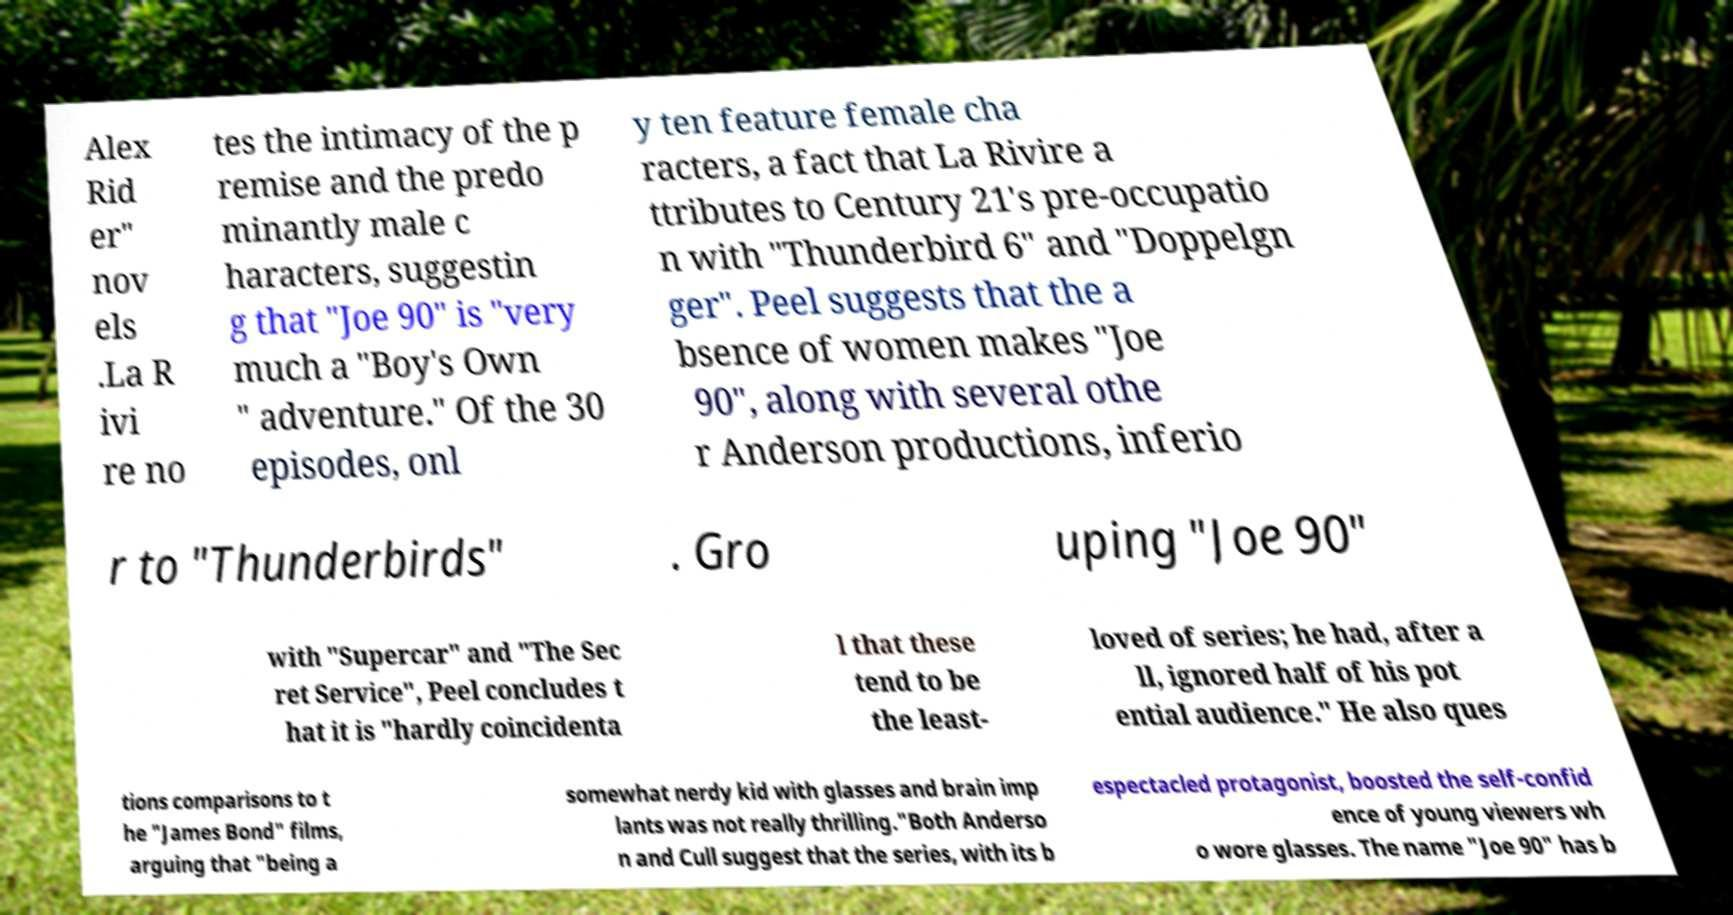I need the written content from this picture converted into text. Can you do that? Alex Rid er" nov els .La R ivi re no tes the intimacy of the p remise and the predo minantly male c haracters, suggestin g that "Joe 90" is "very much a "Boy's Own " adventure." Of the 30 episodes, onl y ten feature female cha racters, a fact that La Rivire a ttributes to Century 21's pre-occupatio n with "Thunderbird 6" and "Doppelgn ger". Peel suggests that the a bsence of women makes "Joe 90", along with several othe r Anderson productions, inferio r to "Thunderbirds" . Gro uping "Joe 90" with "Supercar" and "The Sec ret Service", Peel concludes t hat it is "hardly coincidenta l that these tend to be the least- loved of series; he had, after a ll, ignored half of his pot ential audience." He also ques tions comparisons to t he "James Bond" films, arguing that "being a somewhat nerdy kid with glasses and brain imp lants was not really thrilling."Both Anderso n and Cull suggest that the series, with its b espectacled protagonist, boosted the self-confid ence of young viewers wh o wore glasses. The name "Joe 90" has b 